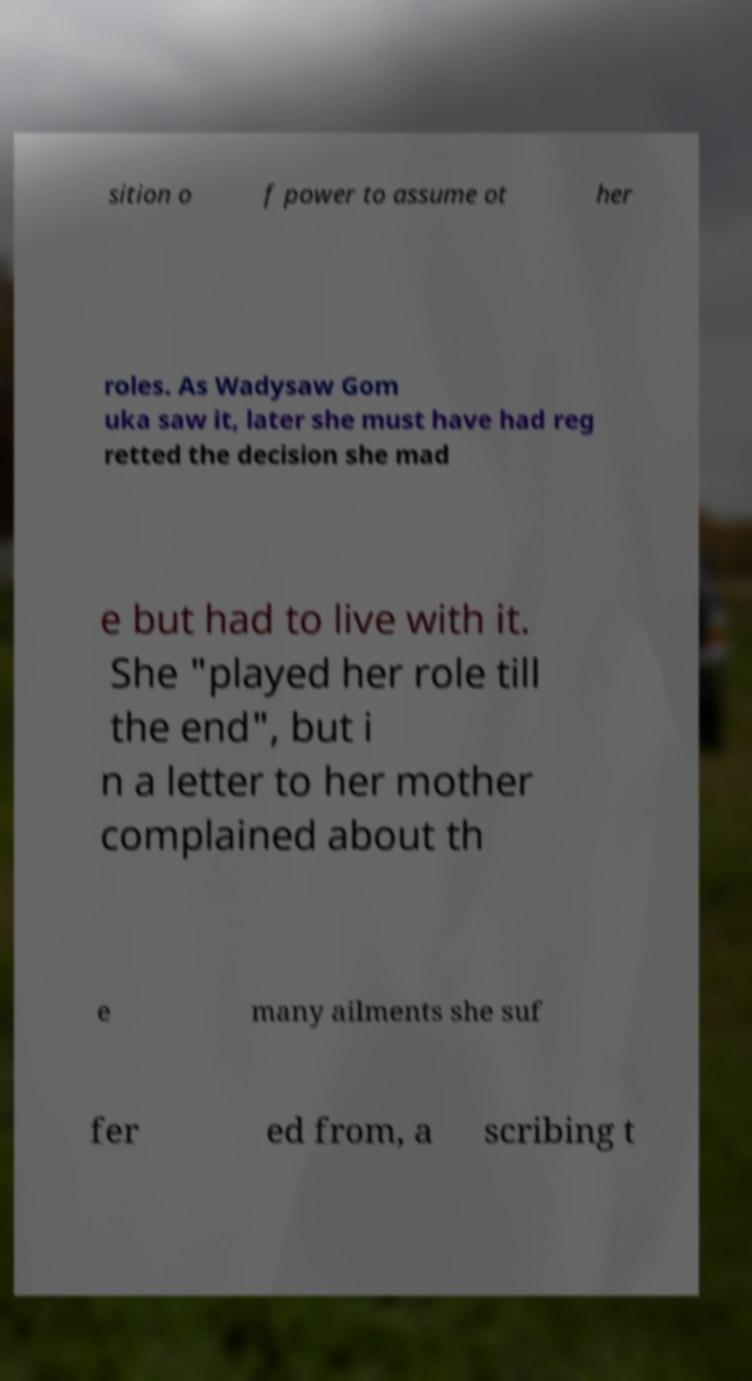Please read and relay the text visible in this image. What does it say? sition o f power to assume ot her roles. As Wadysaw Gom uka saw it, later she must have had reg retted the decision she mad e but had to live with it. She "played her role till the end", but i n a letter to her mother complained about th e many ailments she suf fer ed from, a scribing t 